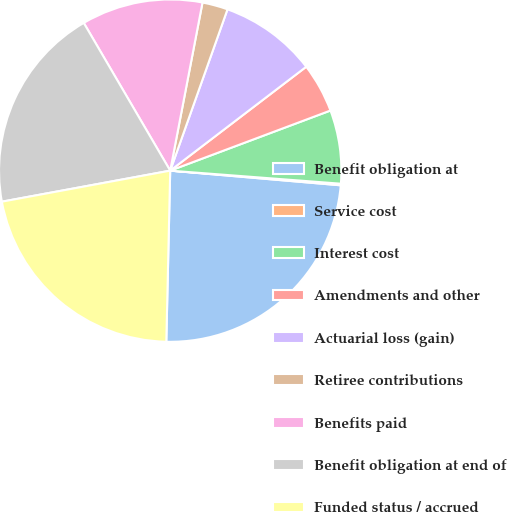Convert chart. <chart><loc_0><loc_0><loc_500><loc_500><pie_chart><fcel>Benefit obligation at<fcel>Service cost<fcel>Interest cost<fcel>Amendments and other<fcel>Actuarial loss (gain)<fcel>Retiree contributions<fcel>Benefits paid<fcel>Benefit obligation at end of<fcel>Funded status / accrued<nl><fcel>24.0%<fcel>0.15%<fcel>6.93%<fcel>4.67%<fcel>9.19%<fcel>2.41%<fcel>11.45%<fcel>19.48%<fcel>21.74%<nl></chart> 